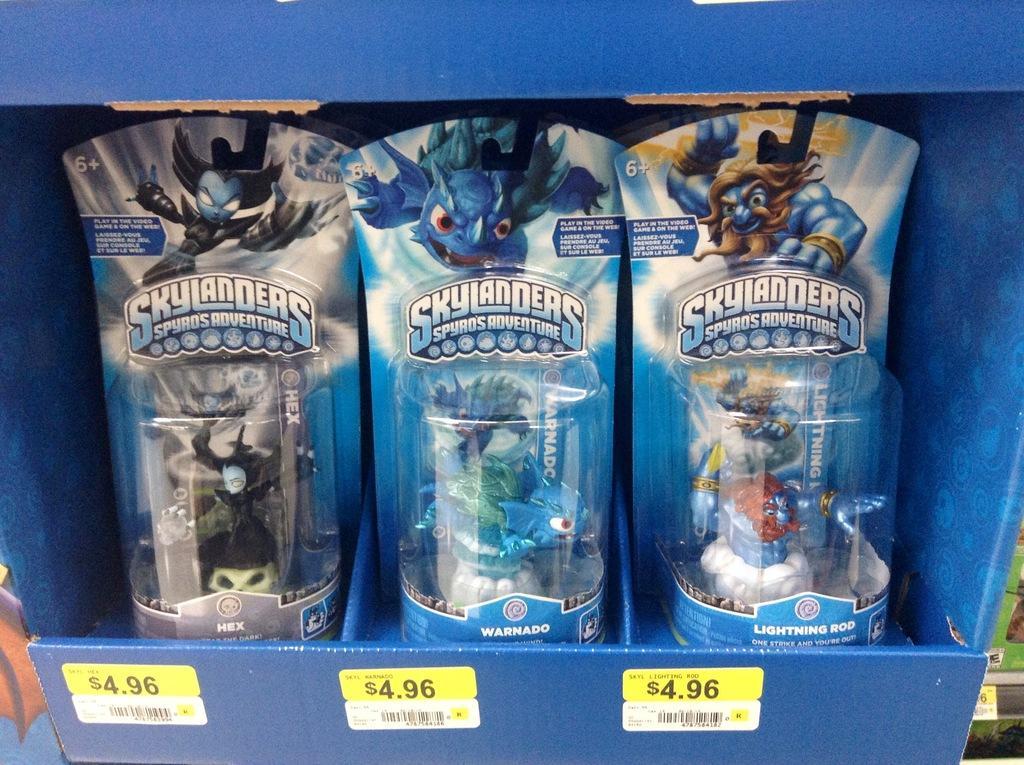Can you describe this image briefly? In this image, we can see a blue color box, in that box we can see three toys and we can see price stickers on the box. 